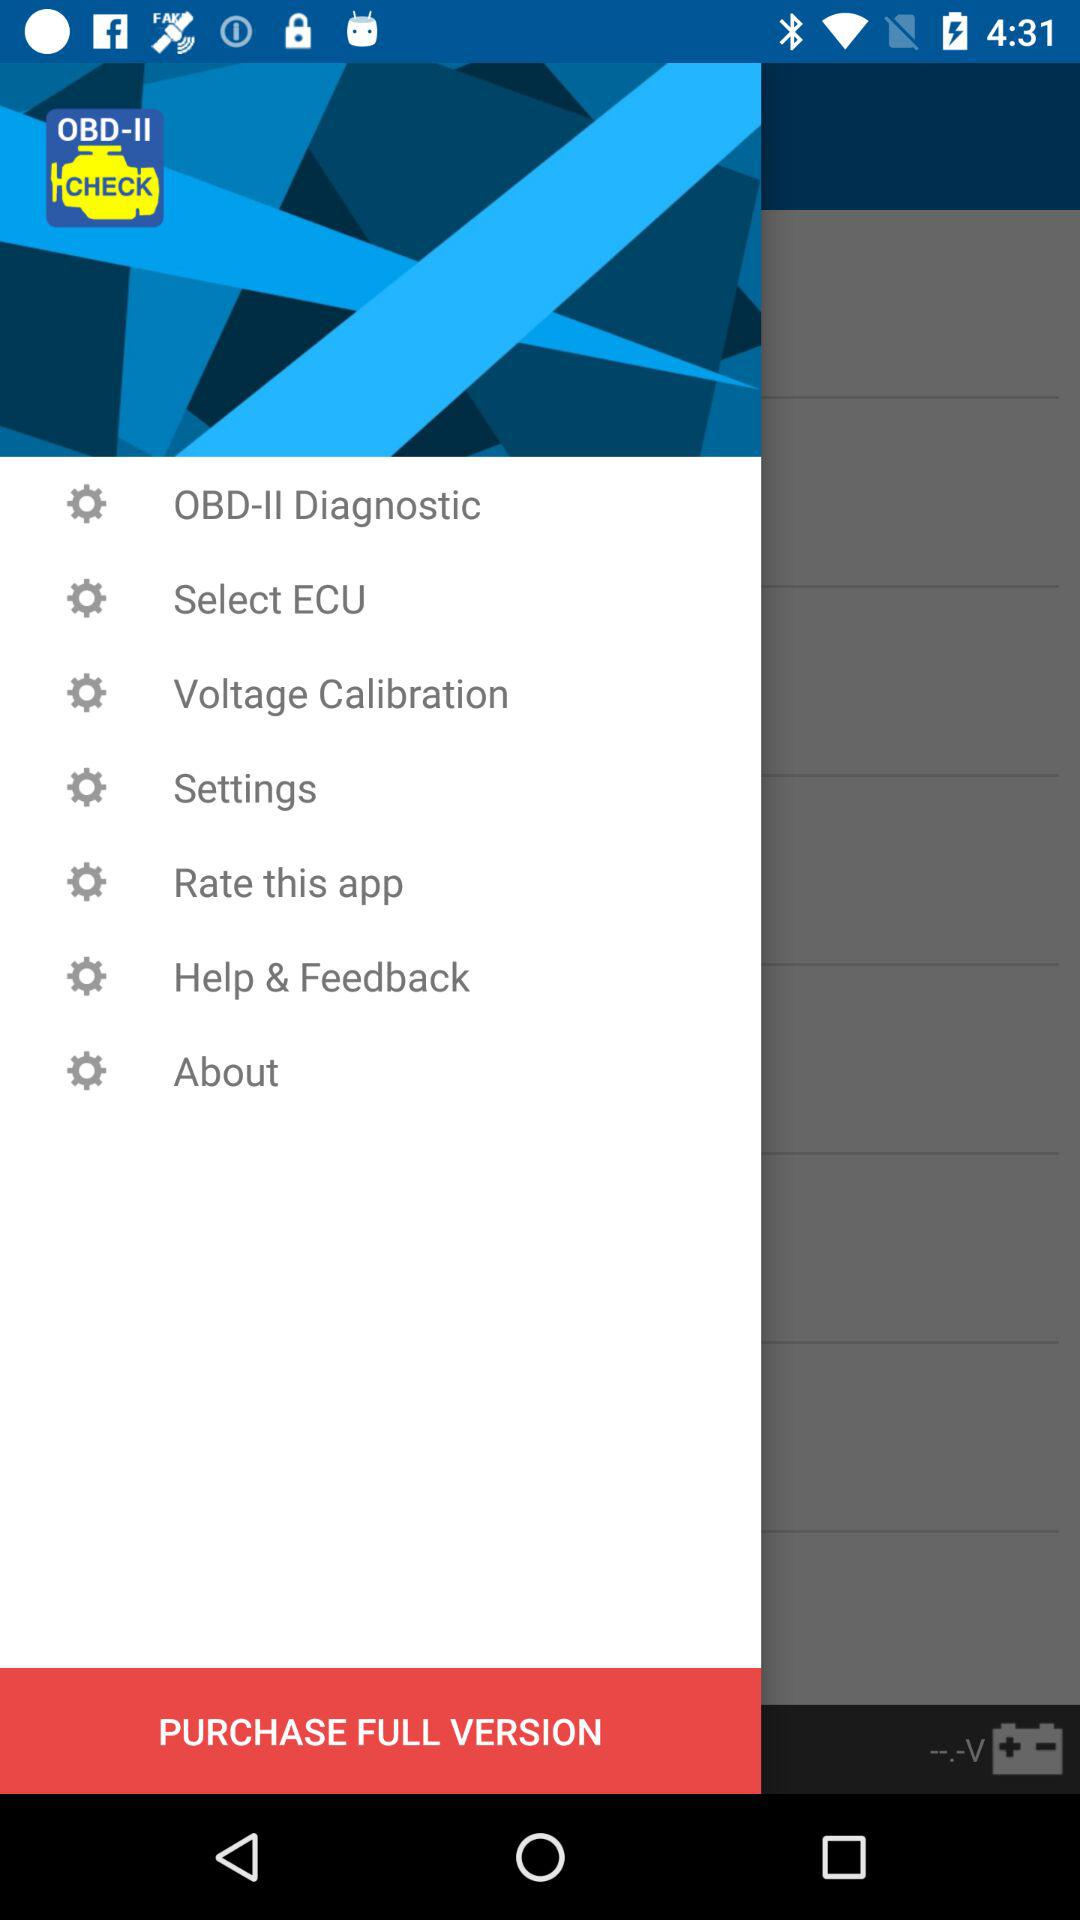What is the application name? The application name is OBD-II Check. 